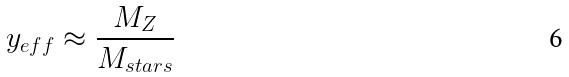Convert formula to latex. <formula><loc_0><loc_0><loc_500><loc_500>y _ { e f f } \approx \frac { M _ { Z } } { M _ { s t a r s } }</formula> 